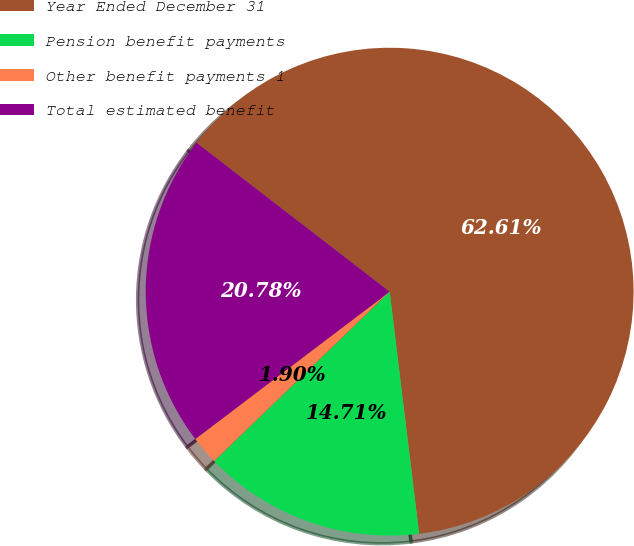Convert chart. <chart><loc_0><loc_0><loc_500><loc_500><pie_chart><fcel>Year Ended December 31<fcel>Pension benefit payments<fcel>Other benefit payments 1<fcel>Total estimated benefit<nl><fcel>62.62%<fcel>14.71%<fcel>1.9%<fcel>20.78%<nl></chart> 